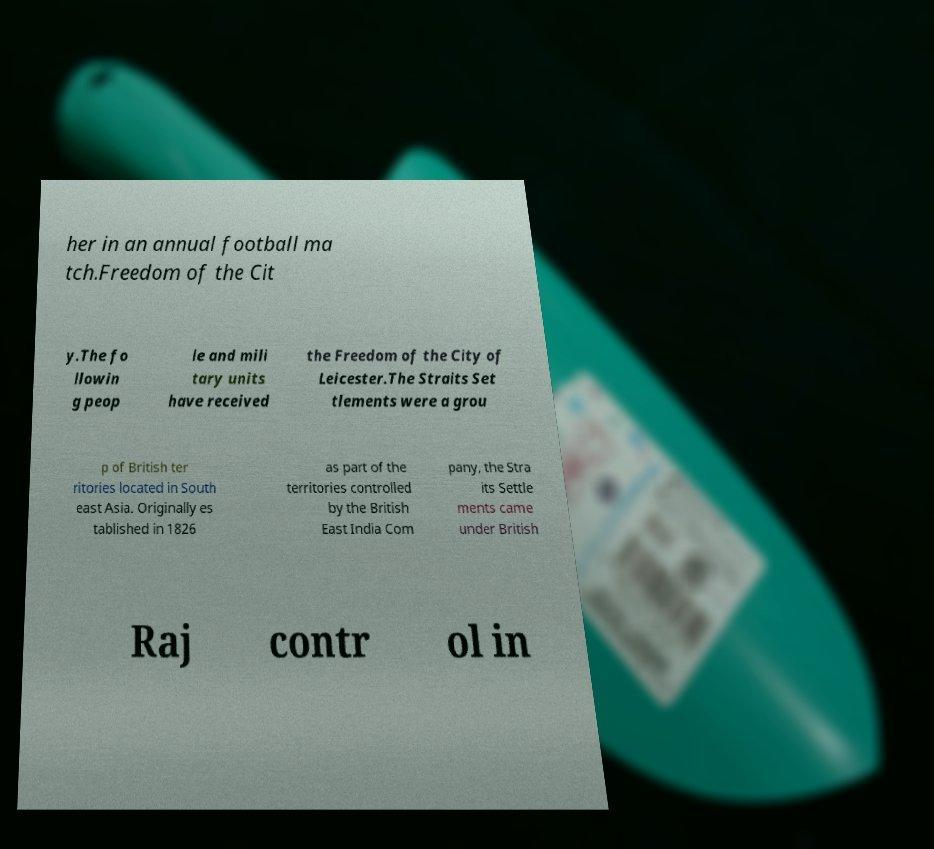For documentation purposes, I need the text within this image transcribed. Could you provide that? her in an annual football ma tch.Freedom of the Cit y.The fo llowin g peop le and mili tary units have received the Freedom of the City of Leicester.The Straits Set tlements were a grou p of British ter ritories located in South east Asia. Originally es tablished in 1826 as part of the territories controlled by the British East India Com pany, the Stra its Settle ments came under British Raj contr ol in 